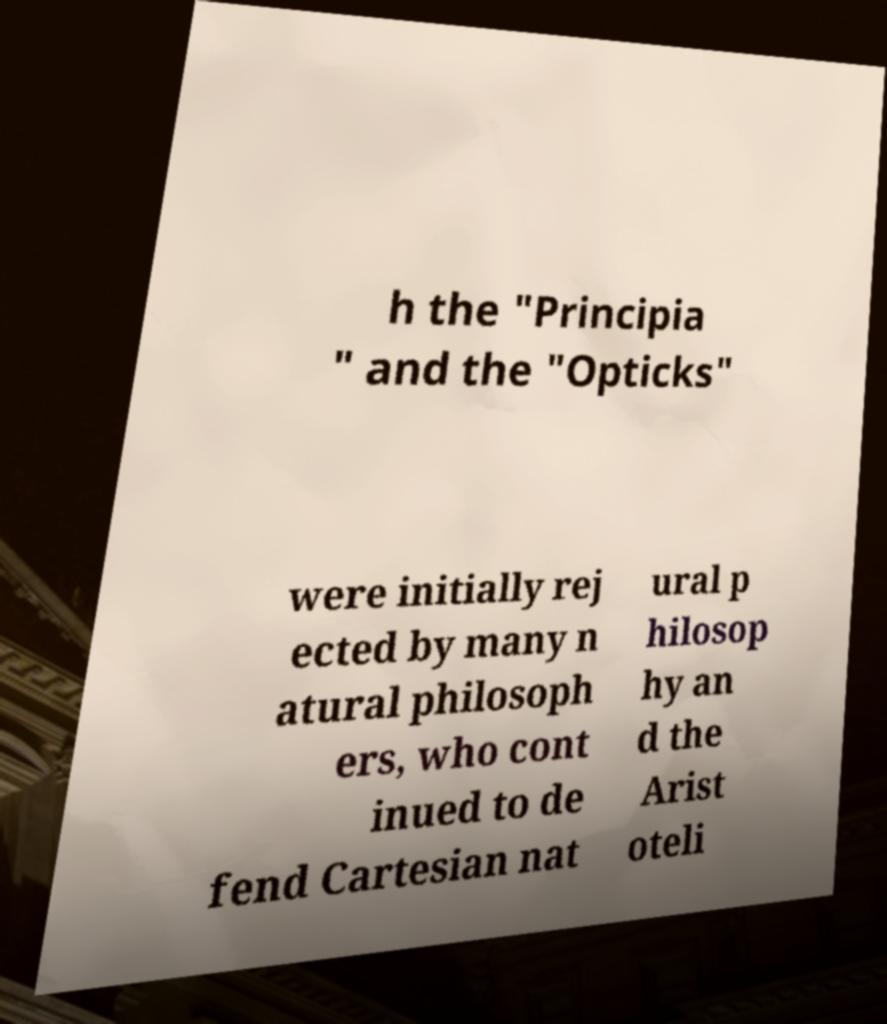I need the written content from this picture converted into text. Can you do that? h the "Principia " and the "Opticks" were initially rej ected by many n atural philosoph ers, who cont inued to de fend Cartesian nat ural p hilosop hy an d the Arist oteli 